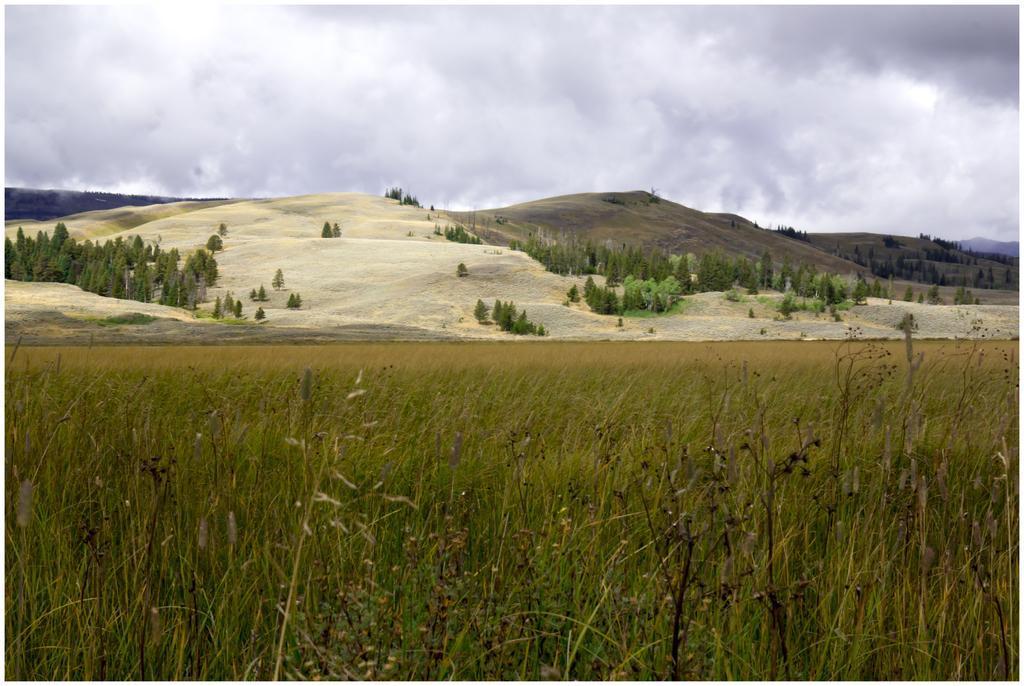Describe this image in one or two sentences. In this picture in the front there are dry plants. In the background there are trees and there are mountains and the sky is cloudy. 